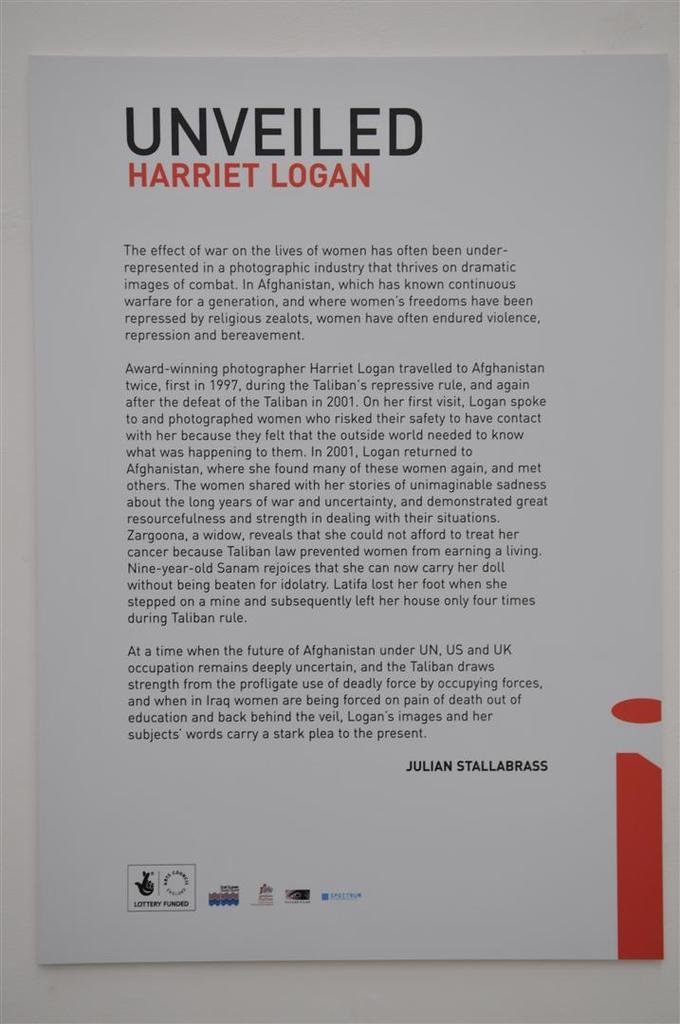<image>
Create a compact narrative representing the image presented. A biography of Harriet Logan as written by Julian Stallabrass. 